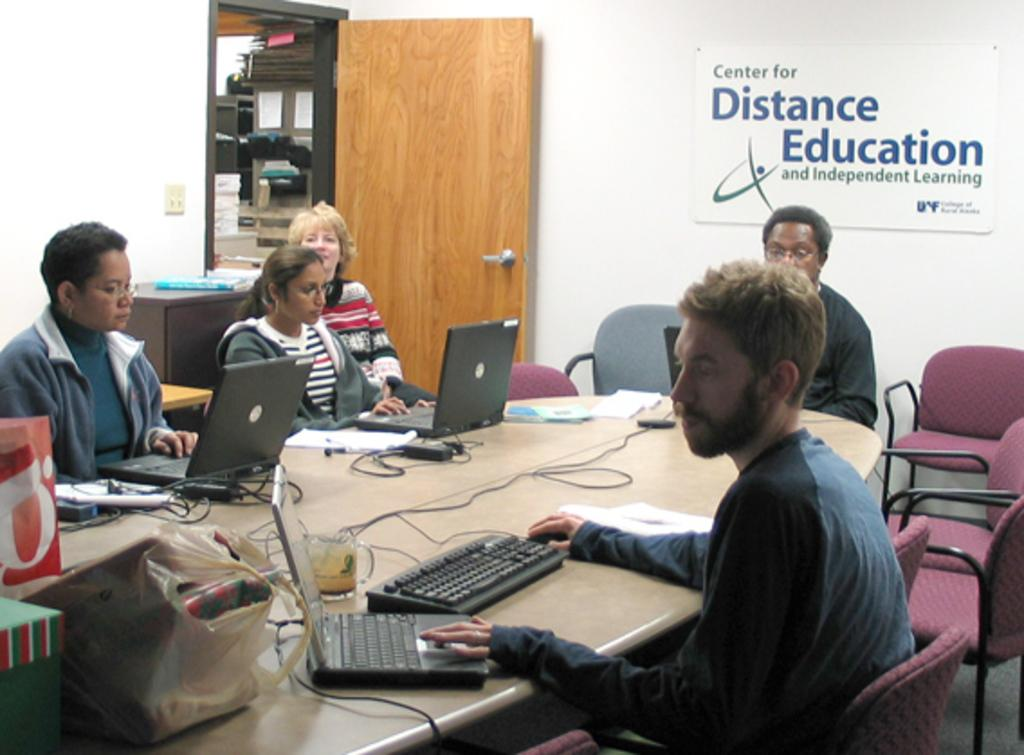<image>
Write a terse but informative summary of the picture. a group of people sitting at a conference table with a sign Center of Distance Education and Independent Learning on the all 